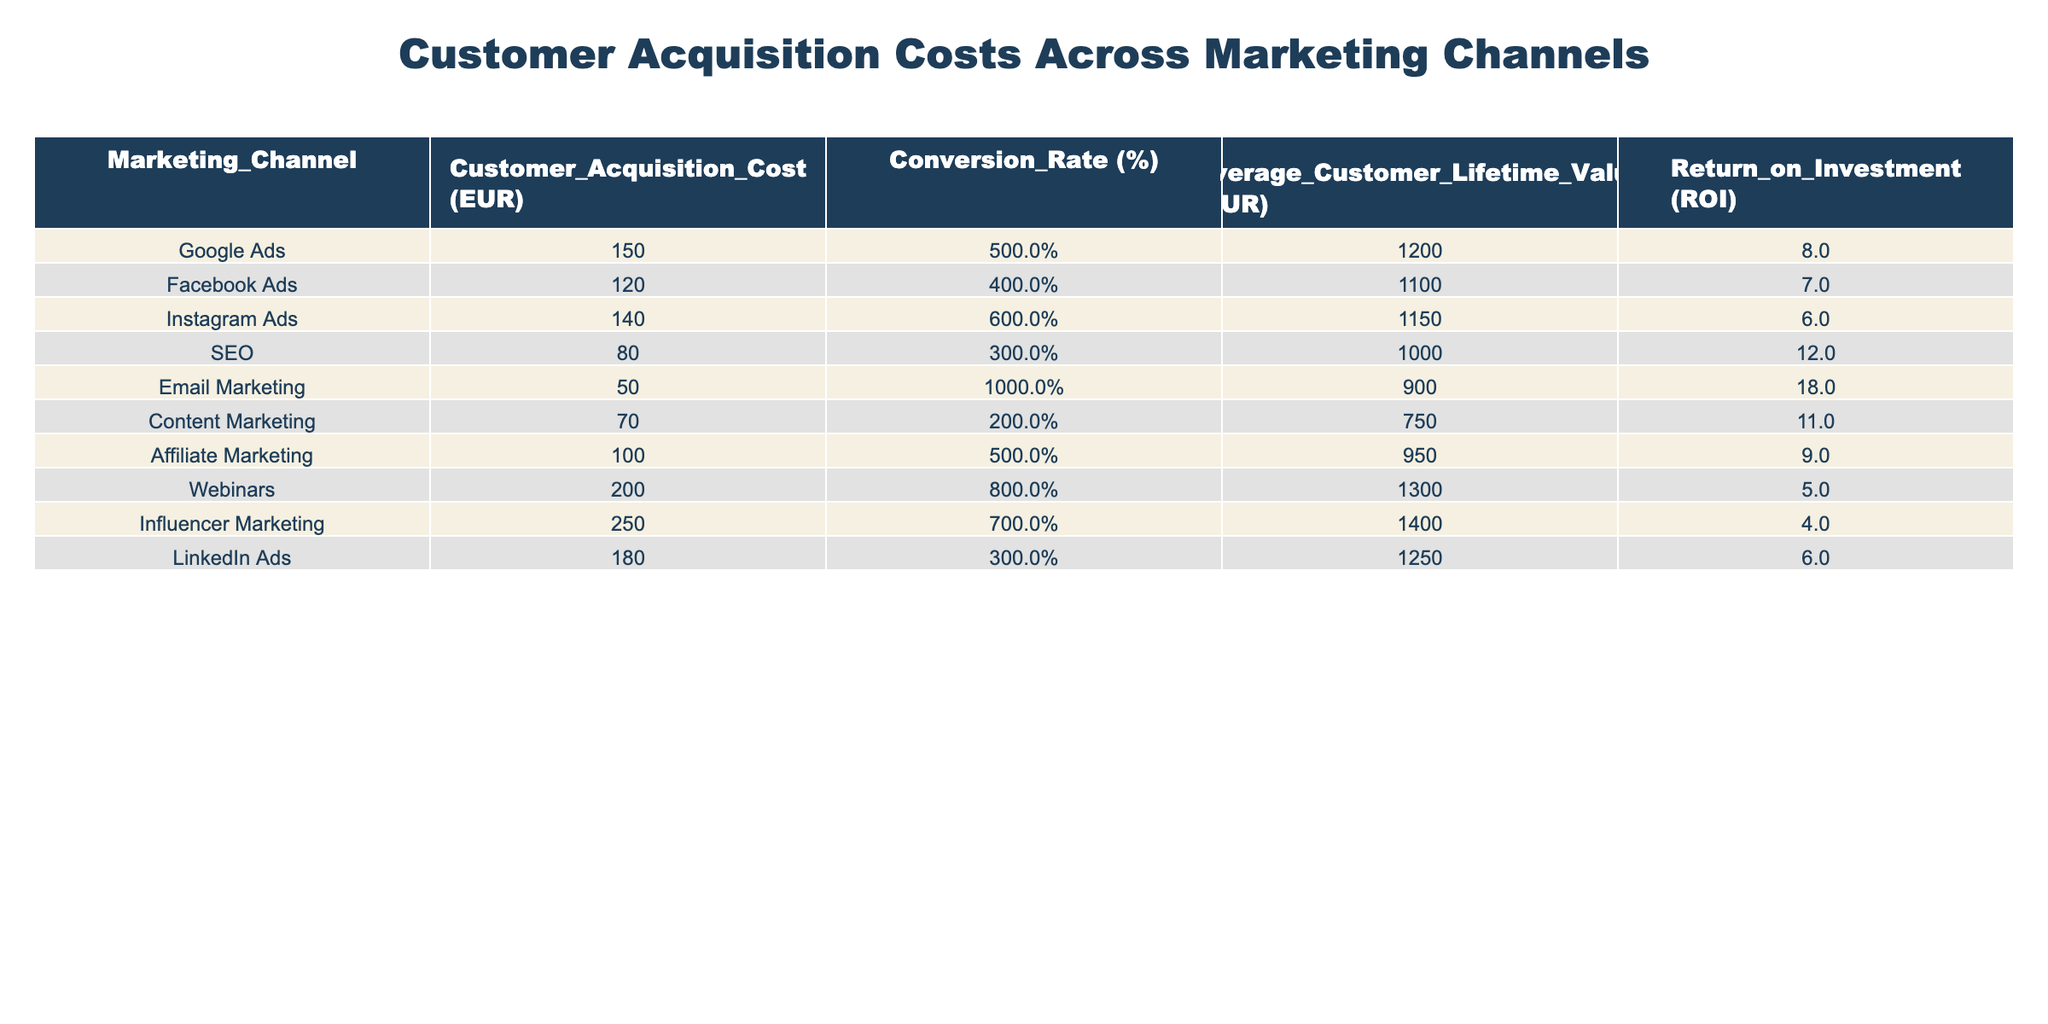What is the Customer Acquisition Cost for Email Marketing? The table shows that the Customer Acquisition Cost for Email Marketing is 50 EUR.
Answer: 50 EUR Which marketing channel has the highest Customer Acquisition Cost? By examining the Customer Acquisition Costs, the channel with the highest cost is Influencer Marketing at 250 EUR.
Answer: Influencer Marketing at 250 EUR What is the Conversion Rate for SEO? The table indicates that the Conversion Rate for SEO is 3%.
Answer: 3% What is the average Customer Acquisition Cost across all channels? To find the average, sum all Customer Acquisition Costs: 150 + 120 + 140 + 80 + 50 + 70 + 100 + 200 + 250 + 180 = 1,490 EUR. Divide by the number of channels (10), so 1,490 EUR / 10 = 149 EUR.
Answer: 149 EUR Does Email Marketing have a higher Return on Investment than Google Ads? For Email Marketing, the ROI is 18, whereas for Google Ads, it is 8. Since 18 is greater than 8, the statement is true.
Answer: Yes Which marketing channel has the lowest Customer Acquisition Cost, and what is it? The table shows that the lowest Customer Acquisition Cost is for Email Marketing at 50 EUR.
Answer: Email Marketing at 50 EUR If we combine the Customer Acquisition Costs of Social Media channels (Facebook, Instagram, and Influencer marketing), what is the total? The Customer Acquisition Costs for the relevant channels are: Facebook Ads (120 EUR), Instagram Ads (140 EUR), and Influencer Marketing (250 EUR). Adding these gives 120 + 140 + 250 = 510 EUR.
Answer: 510 EUR Is the Conversion Rate for Webinars higher than that for Email Marketing? The Conversion Rate for Webinars is 8%, while Email Marketing has a Conversion Rate of 10%. Since 8% is less than 10%, the statement is false.
Answer: No What is the Return on Investment of the channel with the second highest Customer Acquisition Cost? The second highest cost is for LinkedIn Ads at 180 EUR, which has an ROI of 6.
Answer: 6 